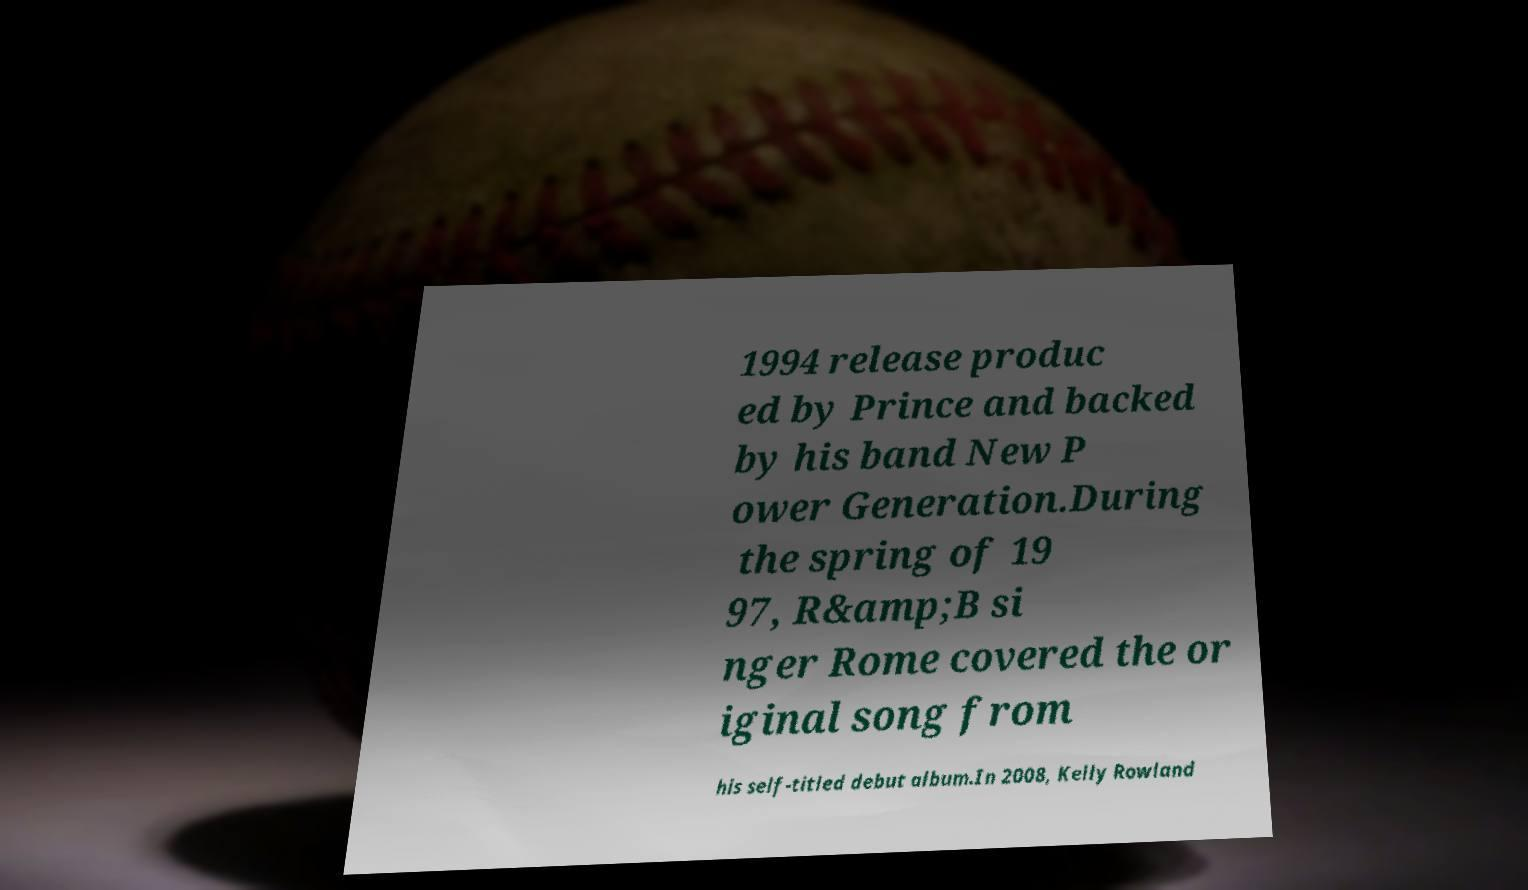For documentation purposes, I need the text within this image transcribed. Could you provide that? 1994 release produc ed by Prince and backed by his band New P ower Generation.During the spring of 19 97, R&amp;B si nger Rome covered the or iginal song from his self-titled debut album.In 2008, Kelly Rowland 